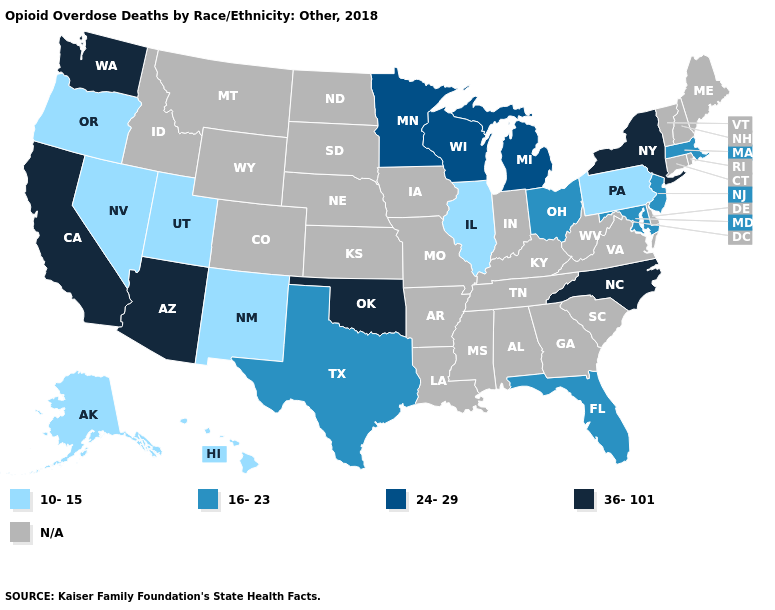Does Maryland have the lowest value in the South?
Short answer required. Yes. What is the value of New Hampshire?
Keep it brief. N/A. What is the value of South Dakota?
Quick response, please. N/A. What is the value of Montana?
Be succinct. N/A. Name the states that have a value in the range 36-101?
Quick response, please. Arizona, California, New York, North Carolina, Oklahoma, Washington. Name the states that have a value in the range 36-101?
Write a very short answer. Arizona, California, New York, North Carolina, Oklahoma, Washington. What is the value of Indiana?
Be succinct. N/A. Name the states that have a value in the range 16-23?
Write a very short answer. Florida, Maryland, Massachusetts, New Jersey, Ohio, Texas. Among the states that border Ohio , which have the lowest value?
Keep it brief. Pennsylvania. What is the value of Utah?
Short answer required. 10-15. Name the states that have a value in the range 10-15?
Write a very short answer. Alaska, Hawaii, Illinois, Nevada, New Mexico, Oregon, Pennsylvania, Utah. Name the states that have a value in the range 10-15?
Answer briefly. Alaska, Hawaii, Illinois, Nevada, New Mexico, Oregon, Pennsylvania, Utah. What is the lowest value in the South?
Concise answer only. 16-23. What is the highest value in states that border Tennessee?
Write a very short answer. 36-101. 